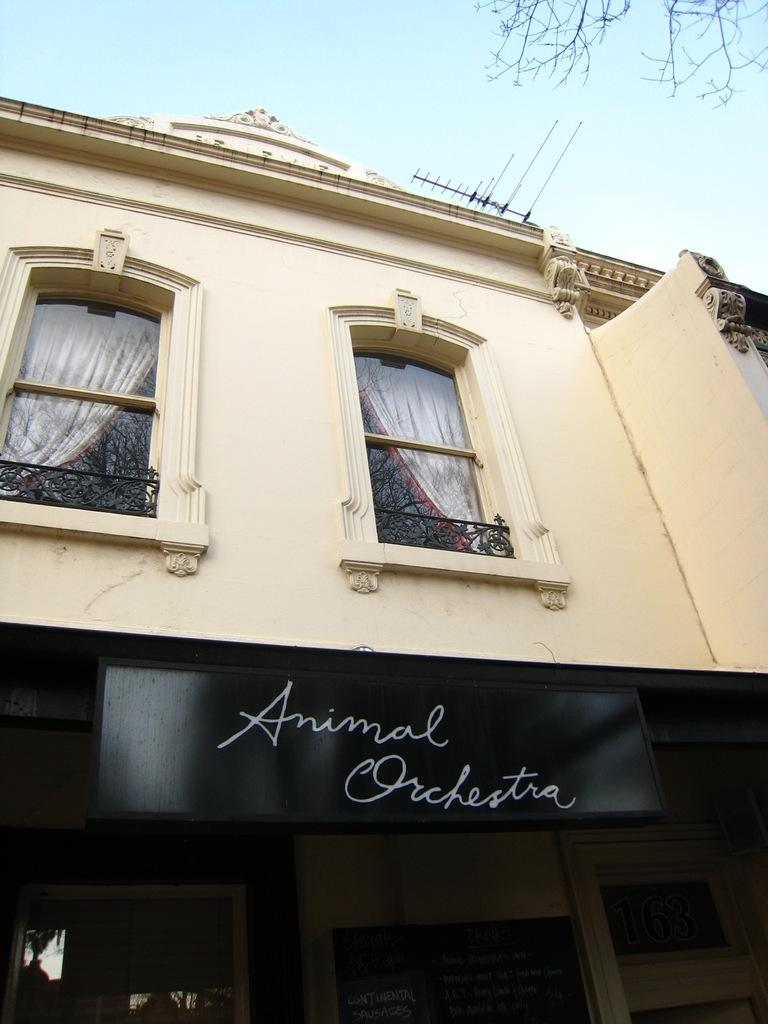What is the main subject in the middle of the picture? There is a building in the middle of the picture. What can be seen in the background of the picture? There is sky visible in the background of the picture. What type of toothbrush is hanging from the building in the image? There is no toothbrush present in the image; it features a building and sky in the background. 